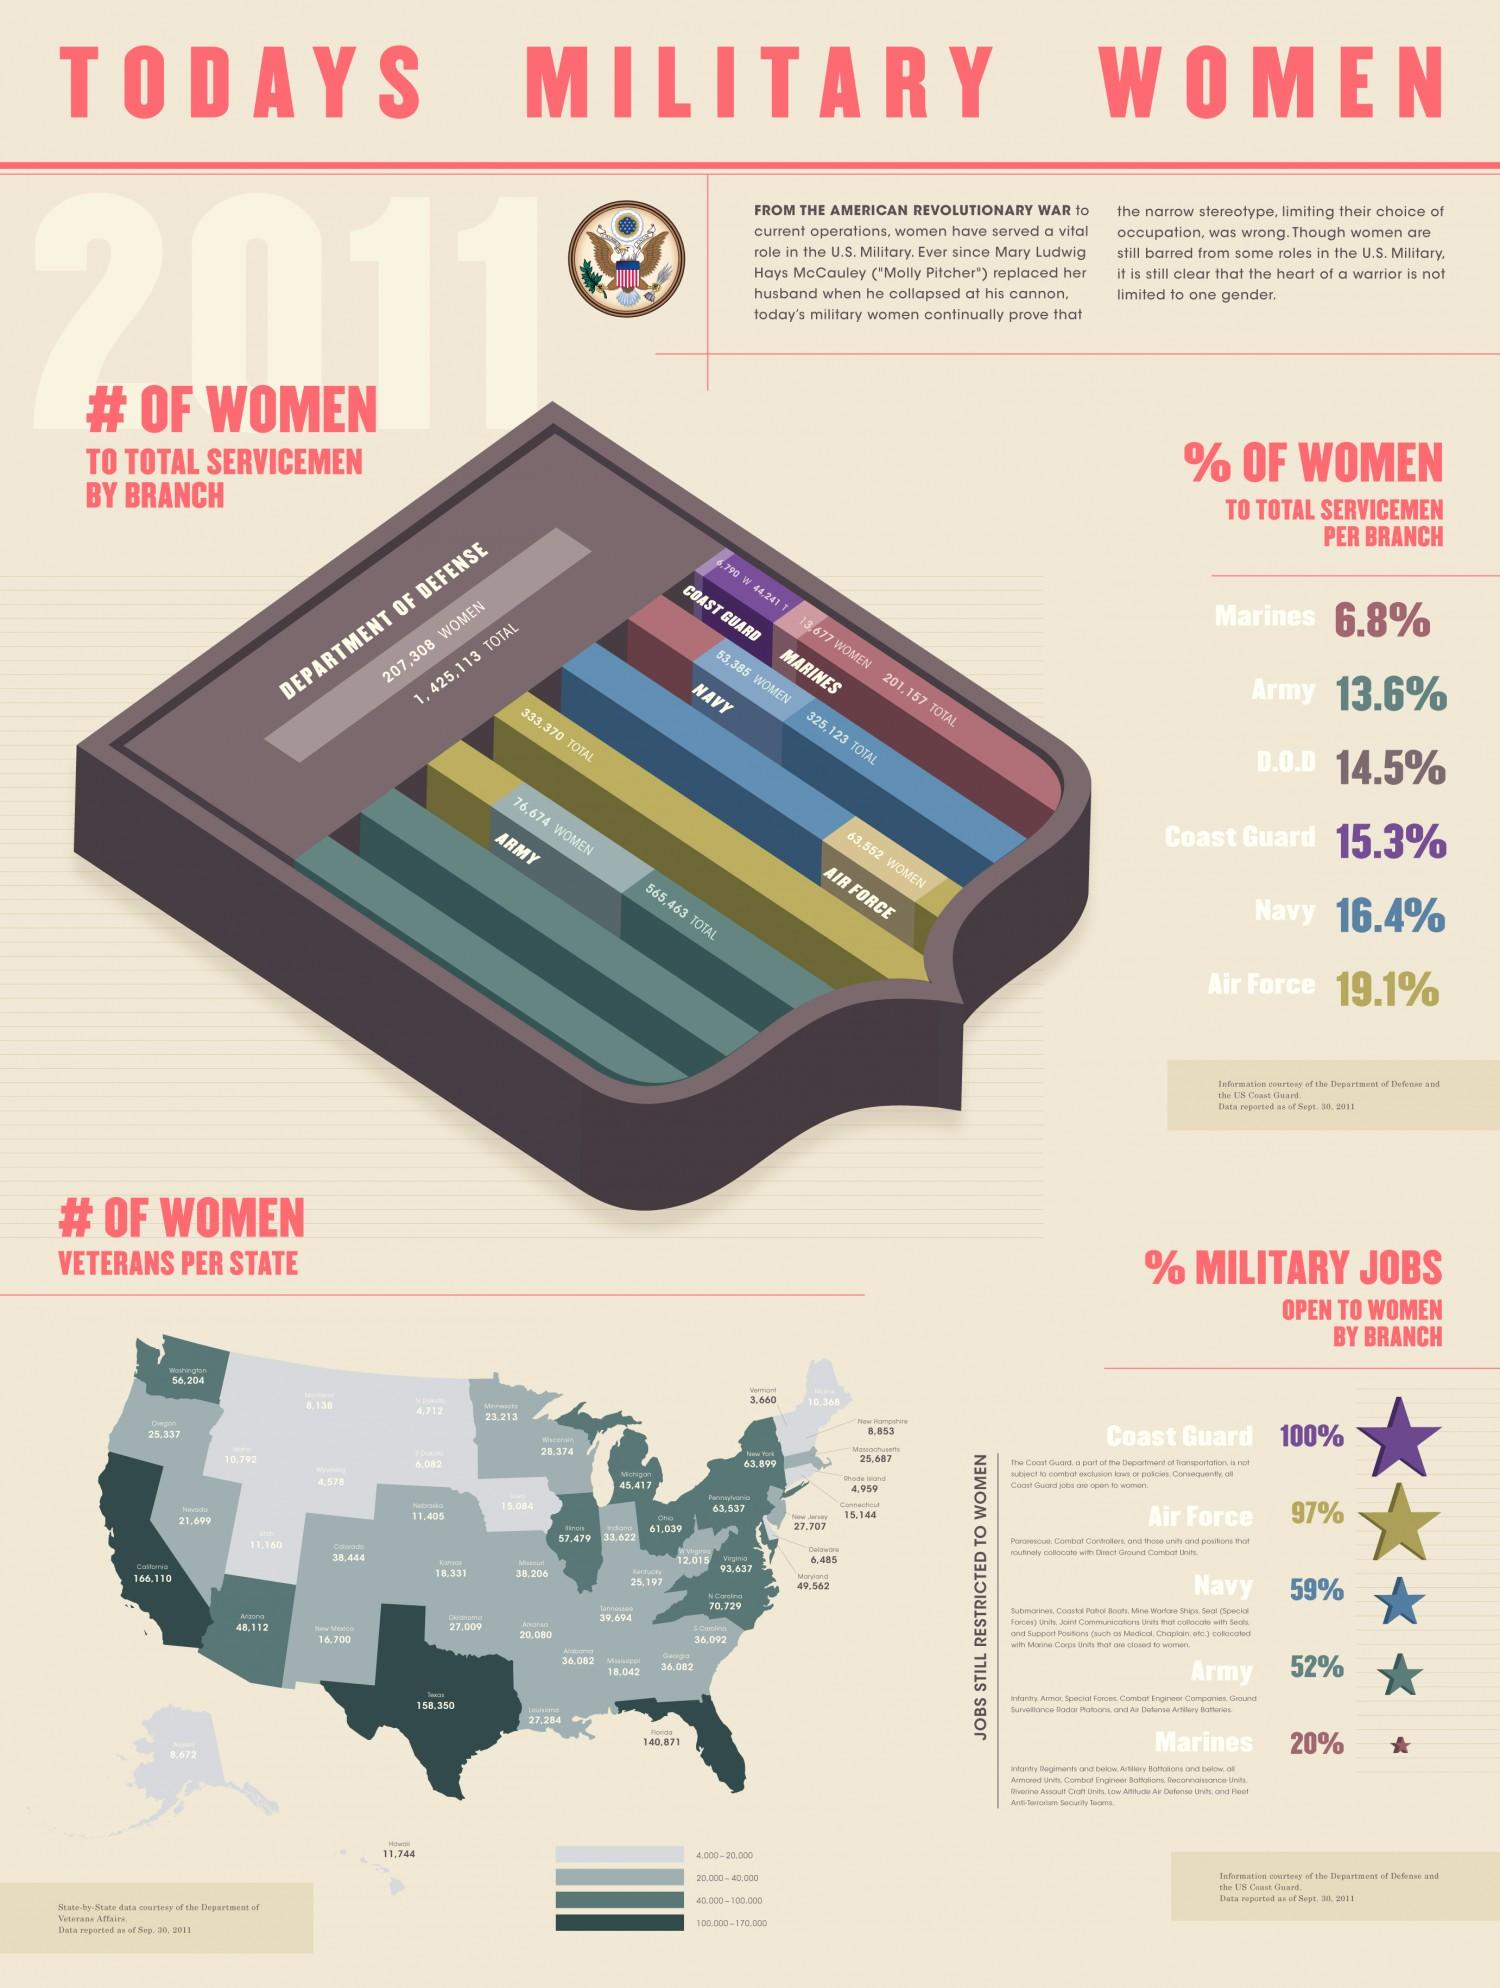Mention a couple of crucial points in this snapshot. Women are the fourth highest in total servicemen among all branches of the military, according to the Department of Defense. The second-highest number of jobs are open to women in the Air Force. The state of Texas has the second-highest number of women veterans, as compared to all other states in the United States. There are three states in the United States that have women veterans within the range of 100,000 to 170,000. The Department of Defense employs a total of 12,17,805 men. 